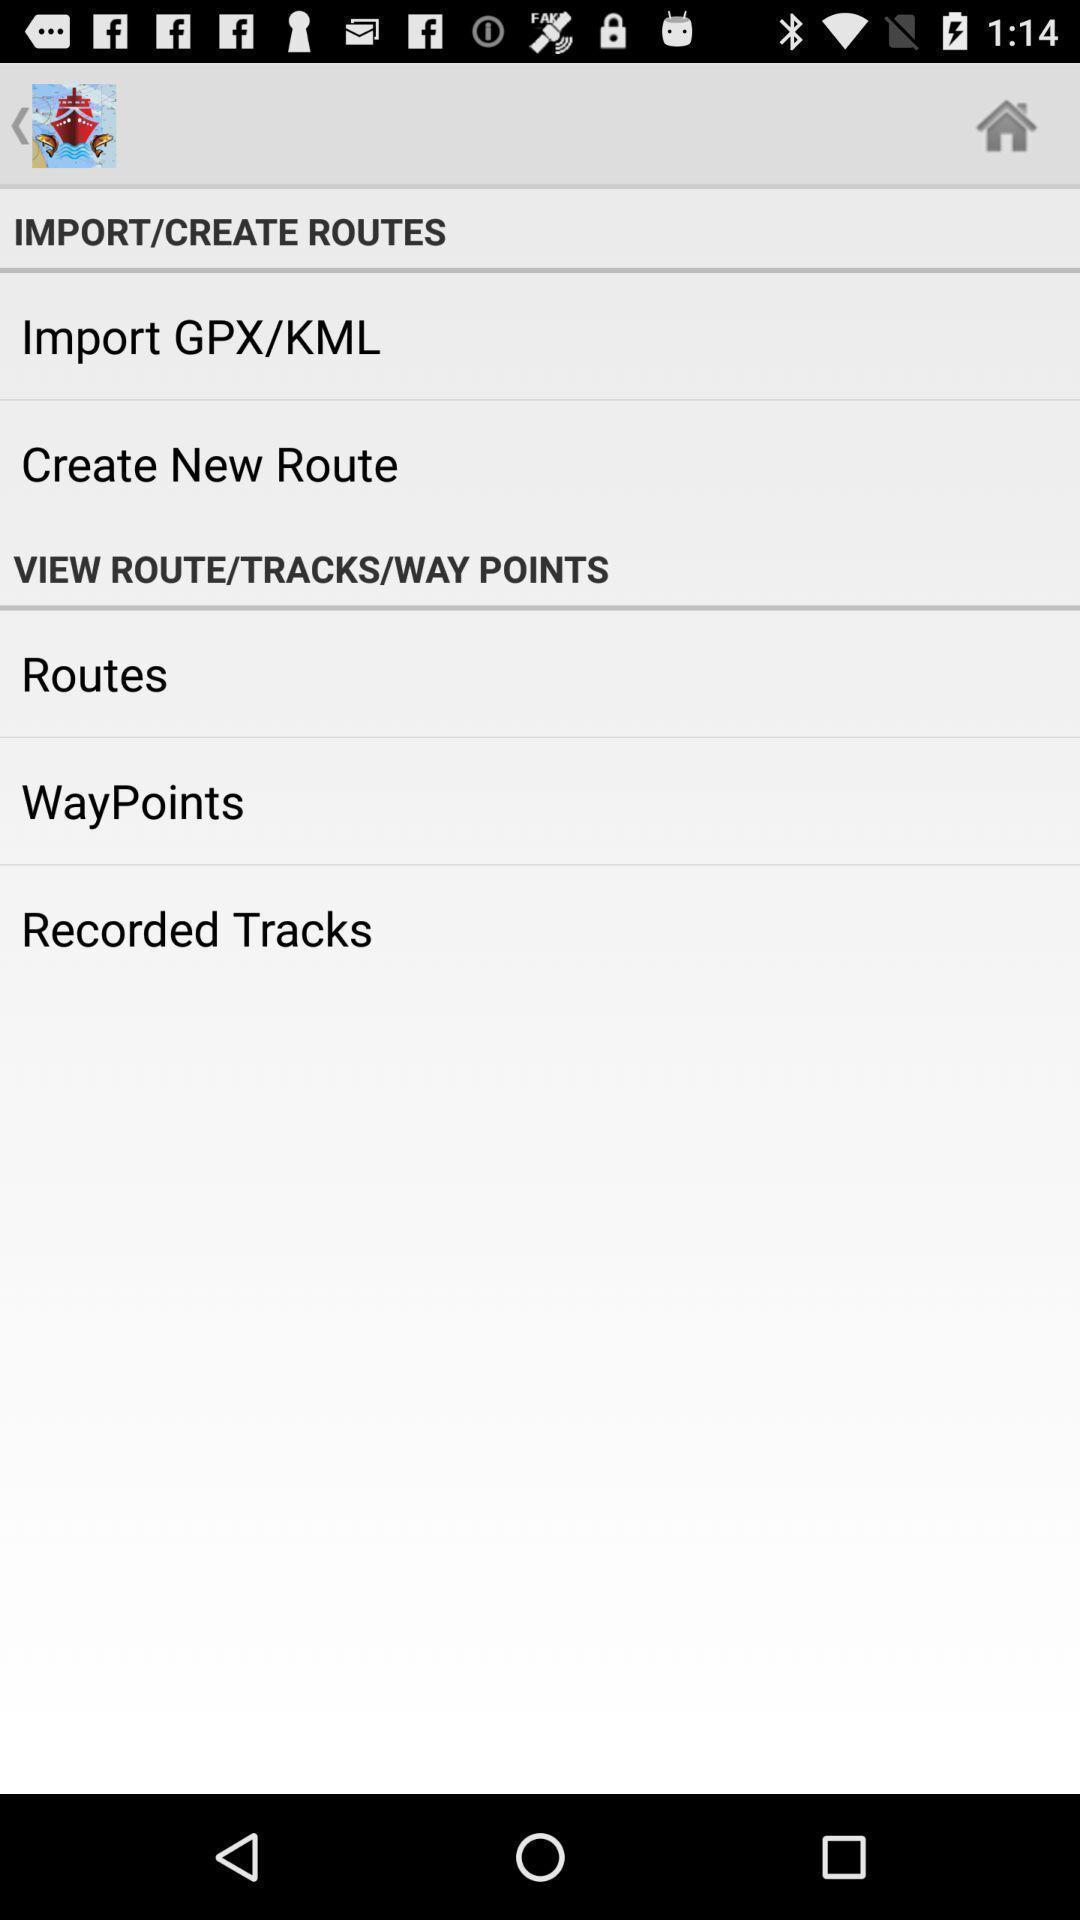Give me a narrative description of this picture. Screen displaying options. 